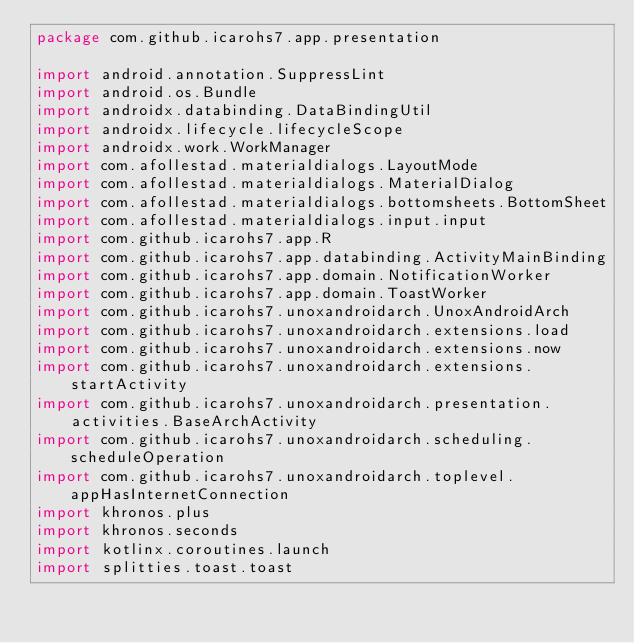<code> <loc_0><loc_0><loc_500><loc_500><_Kotlin_>package com.github.icarohs7.app.presentation

import android.annotation.SuppressLint
import android.os.Bundle
import androidx.databinding.DataBindingUtil
import androidx.lifecycle.lifecycleScope
import androidx.work.WorkManager
import com.afollestad.materialdialogs.LayoutMode
import com.afollestad.materialdialogs.MaterialDialog
import com.afollestad.materialdialogs.bottomsheets.BottomSheet
import com.afollestad.materialdialogs.input.input
import com.github.icarohs7.app.R
import com.github.icarohs7.app.databinding.ActivityMainBinding
import com.github.icarohs7.app.domain.NotificationWorker
import com.github.icarohs7.app.domain.ToastWorker
import com.github.icarohs7.unoxandroidarch.UnoxAndroidArch
import com.github.icarohs7.unoxandroidarch.extensions.load
import com.github.icarohs7.unoxandroidarch.extensions.now
import com.github.icarohs7.unoxandroidarch.extensions.startActivity
import com.github.icarohs7.unoxandroidarch.presentation.activities.BaseArchActivity
import com.github.icarohs7.unoxandroidarch.scheduling.scheduleOperation
import com.github.icarohs7.unoxandroidarch.toplevel.appHasInternetConnection
import khronos.plus
import khronos.seconds
import kotlinx.coroutines.launch
import splitties.toast.toast</code> 